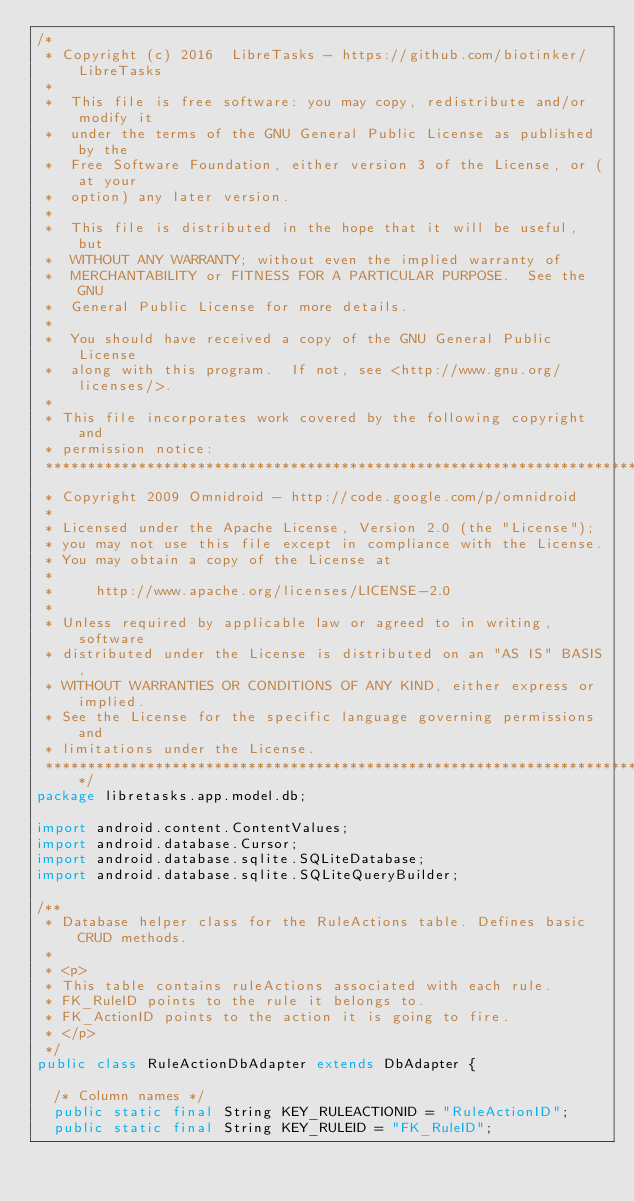<code> <loc_0><loc_0><loc_500><loc_500><_Java_>/*  
 * Copyright (c) 2016  LibreTasks - https://github.com/biotinker/LibreTasks  
 *  
 *  This file is free software: you may copy, redistribute and/or modify it  
 *  under the terms of the GNU General Public License as published by the  
 *  Free Software Foundation, either version 3 of the License, or (at your  
 *  option) any later version.  
 *  
 *  This file is distributed in the hope that it will be useful, but  
 *  WITHOUT ANY WARRANTY; without even the implied warranty of  
 *  MERCHANTABILITY or FITNESS FOR A PARTICULAR PURPOSE.  See the GNU  
 *  General Public License for more details.  
 *  
 *  You should have received a copy of the GNU General Public License  
 *  along with this program.  If not, see <http://www.gnu.org/licenses/>.  
 *  
 * This file incorporates work covered by the following copyright and  
 * permission notice:  
 *******************************************************************************
 * Copyright 2009 Omnidroid - http://code.google.com/p/omnidroid
 *
 * Licensed under the Apache License, Version 2.0 (the "License");
 * you may not use this file except in compliance with the License.
 * You may obtain a copy of the License at
 *
 *     http://www.apache.org/licenses/LICENSE-2.0
 *
 * Unless required by applicable law or agreed to in writing, software
 * distributed under the License is distributed on an "AS IS" BASIS,
 * WITHOUT WARRANTIES OR CONDITIONS OF ANY KIND, either express or implied.
 * See the License for the specific language governing permissions and
 * limitations under the License.
 *******************************************************************************/
package libretasks.app.model.db;

import android.content.ContentValues;
import android.database.Cursor;
import android.database.sqlite.SQLiteDatabase;
import android.database.sqlite.SQLiteQueryBuilder;

/**
 * Database helper class for the RuleActions table. Defines basic CRUD methods. 
 * 
 * <p>
 * This table contains ruleActions associated with each rule.
 * FK_RuleID points to the rule it belongs to.
 * FK_ActionID points to the action it is going to fire.
 * </p>
 */
public class RuleActionDbAdapter extends DbAdapter {

  /* Column names */
  public static final String KEY_RULEACTIONID = "RuleActionID";
  public static final String KEY_RULEID = "FK_RuleID";</code> 